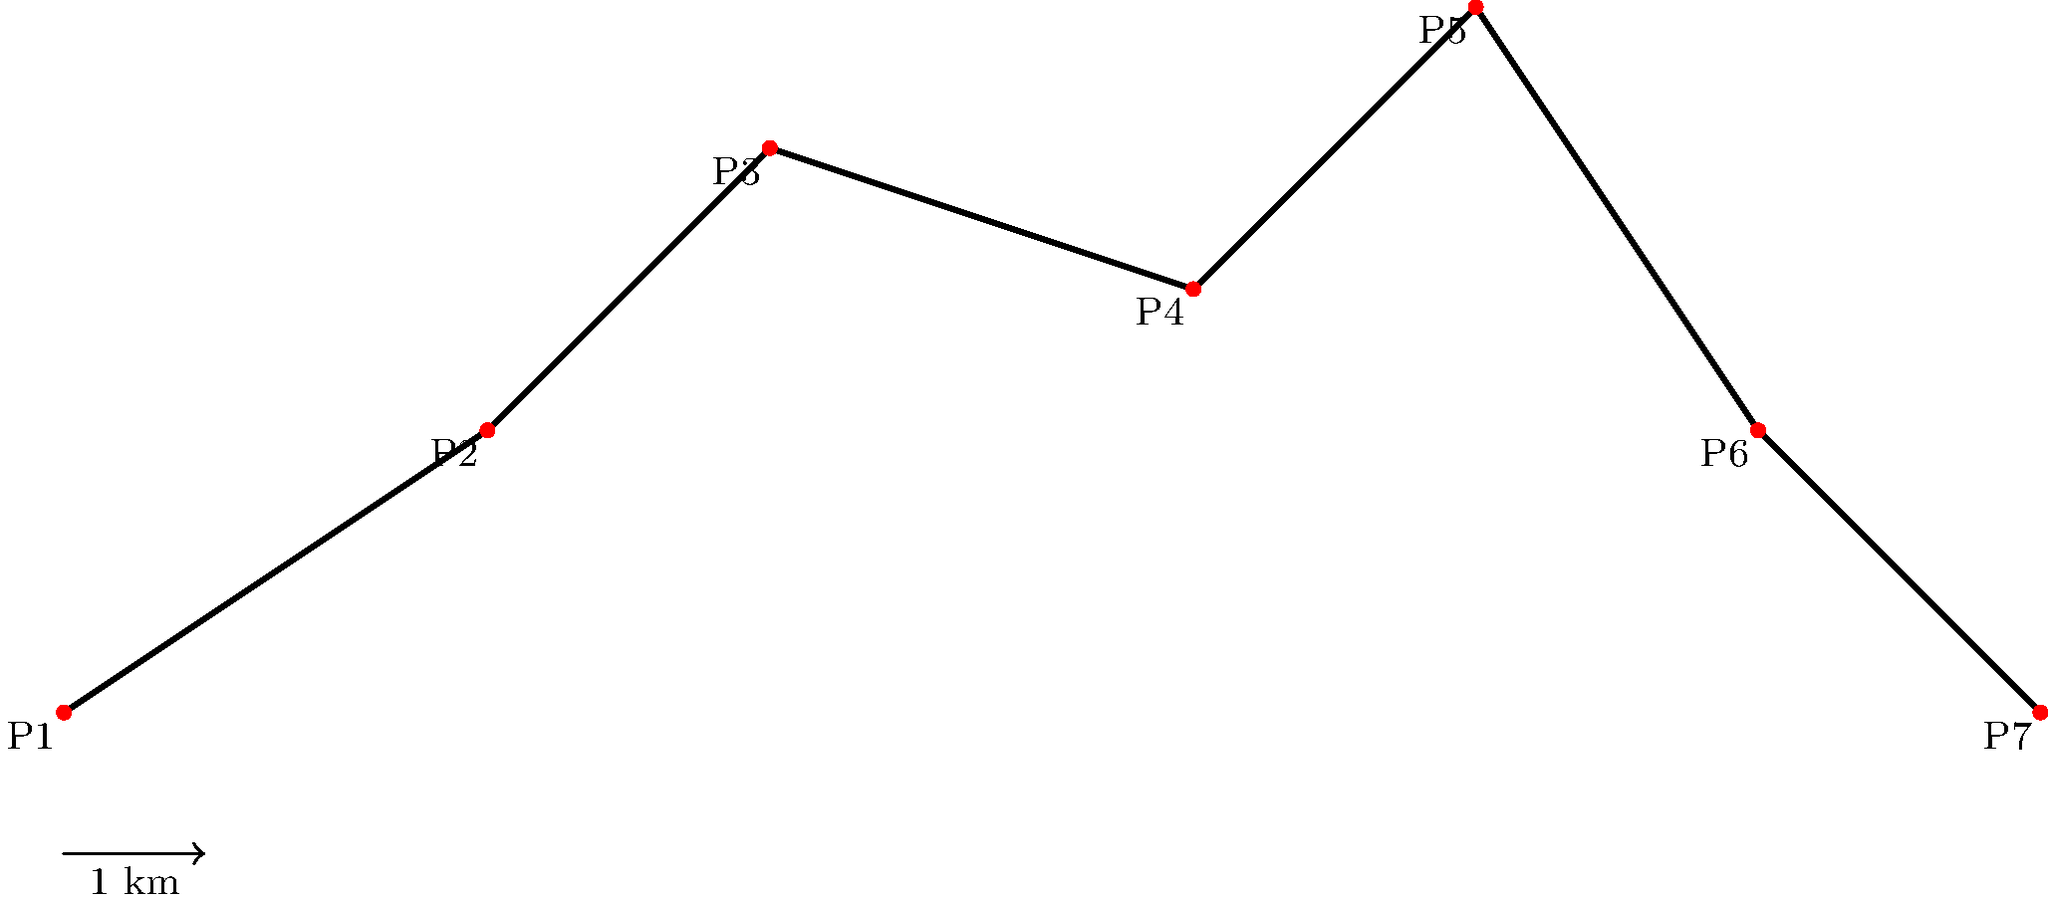The Berlin Wall, a symbol of the Cold War era, was a complex structure with various segments. The diagram above represents a simplified model of a section of the Berlin Wall, where each point (P1 to P7) represents a major turning point in the wall's course. Given that each unit in the diagram represents 1 kilometer, calculate the total perimeter of this section of the Berlin Wall. To calculate the perimeter of this section of the Berlin Wall, we need to sum up the lengths of all line segments connecting the points P1 to P7. We can use the distance formula between two points to calculate each segment's length.

The distance formula is: $d = \sqrt{(x_2 - x_1)^2 + (y_2 - y_1)^2}$

Let's calculate the length of each segment:

1) P1 to P2: $d_{1,2} = \sqrt{(3-0)^2 + (2-0)^2} = \sqrt{13} \approx 3.61$ km
2) P2 to P3: $d_{2,3} = \sqrt{(5-3)^2 + (4-2)^2} = \sqrt{8} \approx 2.83$ km
3) P3 to P4: $d_{3,4} = \sqrt{(8-5)^2 + (3-4)^2} = \sqrt{10} \approx 3.16$ km
4) P4 to P5: $d_{4,5} = \sqrt{(10-8)^2 + (5-3)^2} = \sqrt{8} \approx 2.83$ km
5) P5 to P6: $d_{5,6} = \sqrt{(12-10)^2 + (2-5)^2} = \sqrt{13} \approx 3.61$ km
6) P6 to P7: $d_{6,7} = \sqrt{(14-12)^2 + (0-2)^2} = \sqrt{8} \approx 2.83$ km

Now, we sum up all these distances:

Total perimeter $= d_{1,2} + d_{2,3} + d_{3,4} + d_{4,5} + d_{5,6} + d_{6,7}$
$\approx 3.61 + 2.83 + 3.16 + 2.83 + 3.61 + 2.83$
$\approx 18.87$ km

Therefore, the total perimeter of this section of the Berlin Wall is approximately 18.87 kilometers.
Answer: 18.87 km 